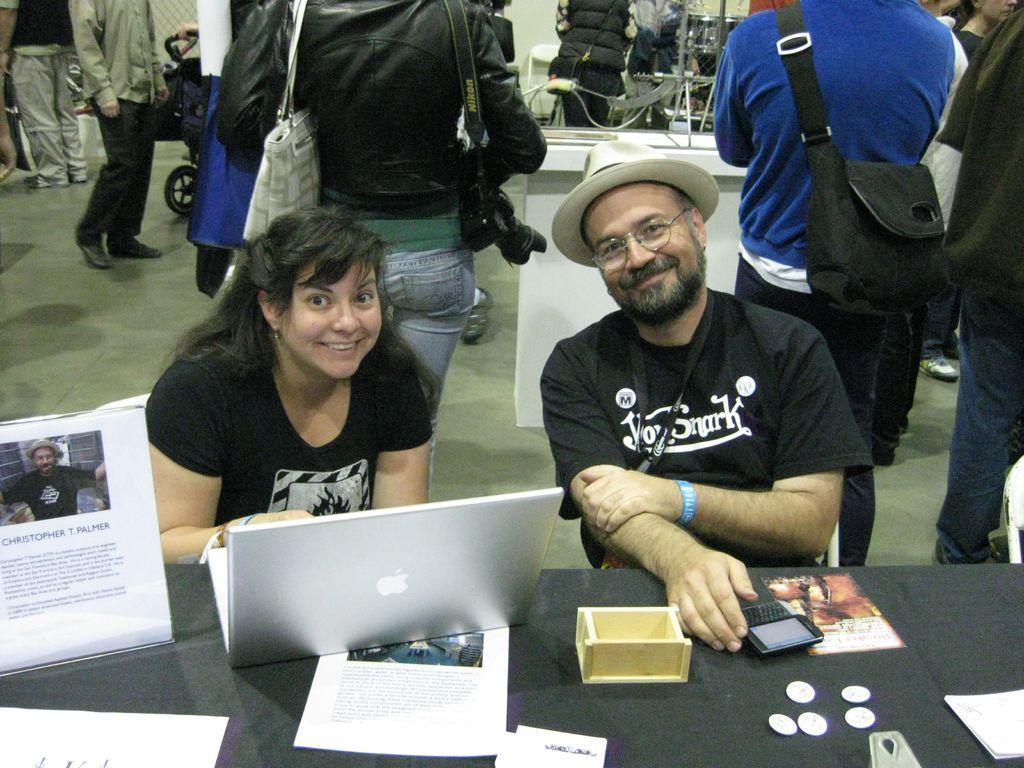Describe this image in one or two sentences. In this picture we can observe two persons sitting in front of a table on which we can observe mobile, papers, laptop and some coins. We can observe a woman and a man. Both of them were smiling. In the background there are some people standing wearing bags on their shoulders. 